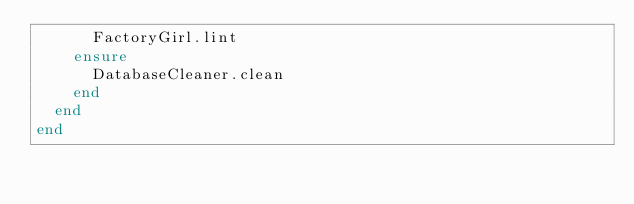<code> <loc_0><loc_0><loc_500><loc_500><_Ruby_>      FactoryGirl.lint
    ensure
      DatabaseCleaner.clean
    end
  end
end
</code> 